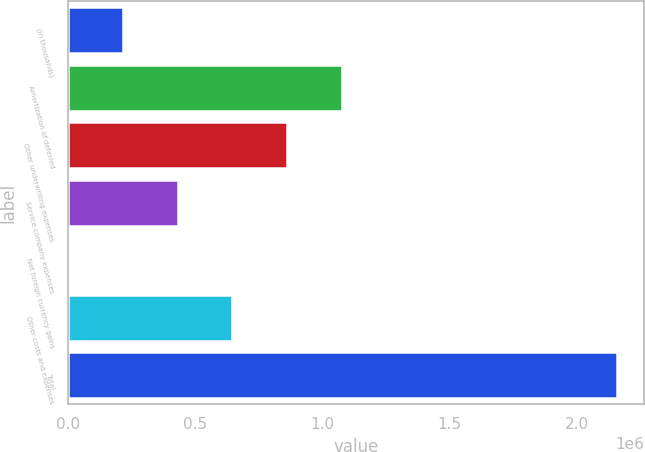Convert chart. <chart><loc_0><loc_0><loc_500><loc_500><bar_chart><fcel>(In thousands)<fcel>Amortization of deferred<fcel>Other underwriting expenses<fcel>Service company expenses<fcel>Net foreign currency gains<fcel>Other costs and expenses<fcel>Total<nl><fcel>215770<fcel>1.07874e+06<fcel>862999<fcel>431513<fcel>27<fcel>647256<fcel>2.15746e+06<nl></chart> 